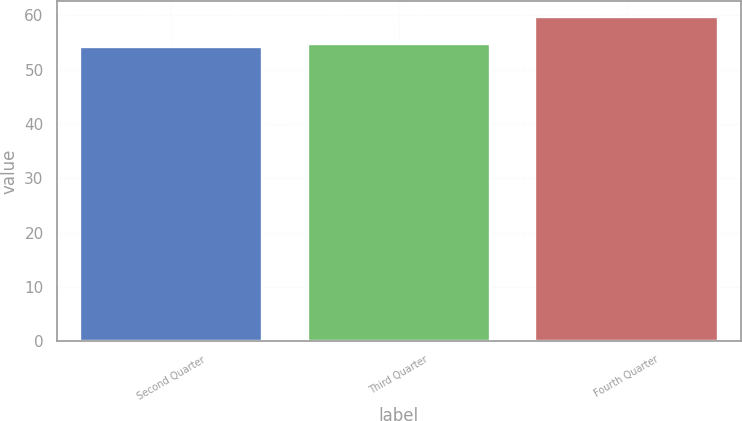Convert chart to OTSL. <chart><loc_0><loc_0><loc_500><loc_500><bar_chart><fcel>Second Quarter<fcel>Third Quarter<fcel>Fourth Quarter<nl><fcel>54.13<fcel>54.68<fcel>59.59<nl></chart> 